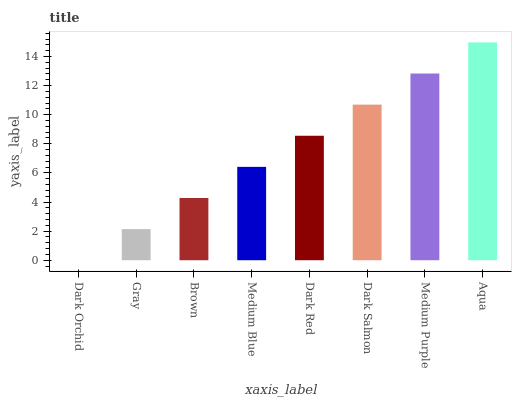Is Dark Orchid the minimum?
Answer yes or no. Yes. Is Aqua the maximum?
Answer yes or no. Yes. Is Gray the minimum?
Answer yes or no. No. Is Gray the maximum?
Answer yes or no. No. Is Gray greater than Dark Orchid?
Answer yes or no. Yes. Is Dark Orchid less than Gray?
Answer yes or no. Yes. Is Dark Orchid greater than Gray?
Answer yes or no. No. Is Gray less than Dark Orchid?
Answer yes or no. No. Is Dark Red the high median?
Answer yes or no. Yes. Is Medium Blue the low median?
Answer yes or no. Yes. Is Medium Blue the high median?
Answer yes or no. No. Is Dark Orchid the low median?
Answer yes or no. No. 